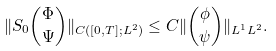Convert formula to latex. <formula><loc_0><loc_0><loc_500><loc_500>\| S _ { 0 } { \Phi \choose \Psi } \| _ { C ( [ 0 , T ] ; L ^ { 2 } ) } \leq C \| { \phi \choose \psi } \| _ { L ^ { 1 } L ^ { 2 } } .</formula> 